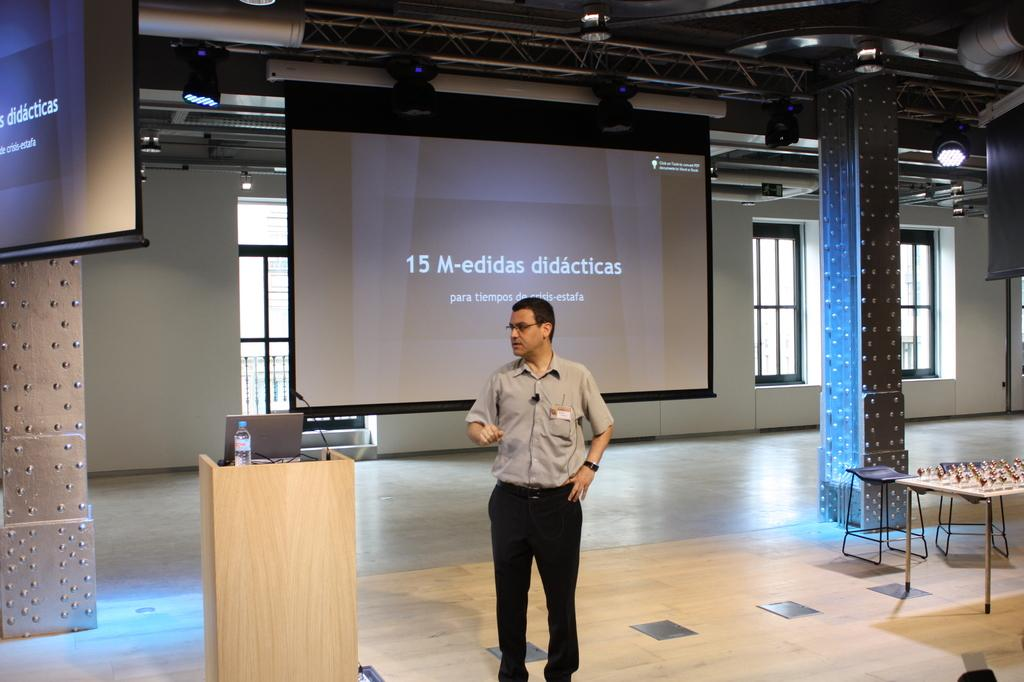<image>
Summarize the visual content of the image. A man stands in front of a screen that reads "15 M-edidas didactias." 